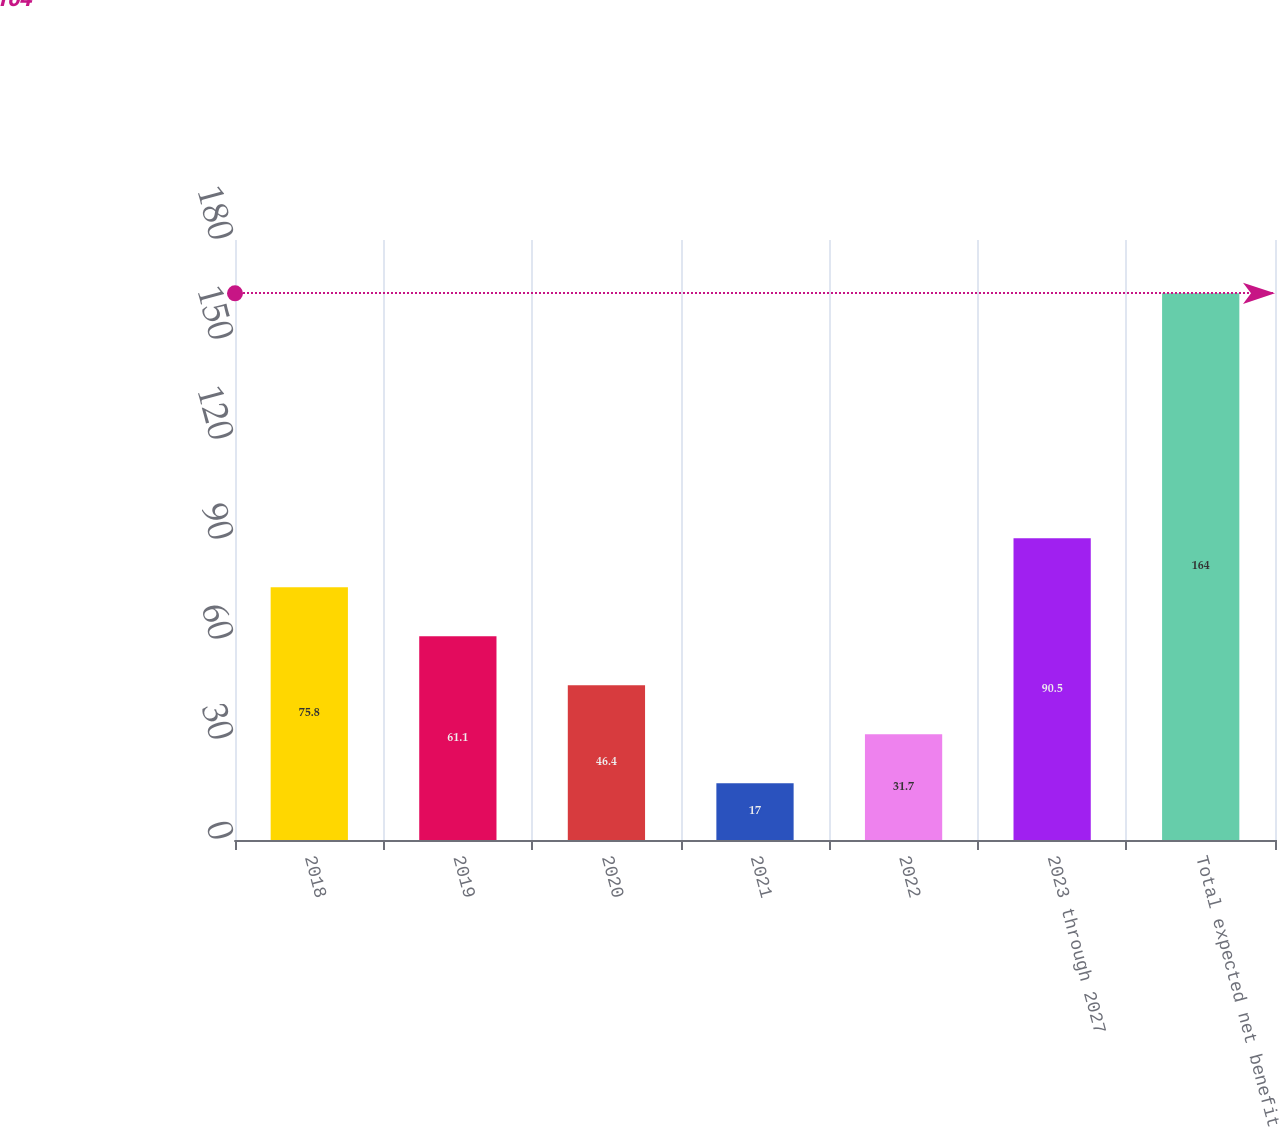Convert chart. <chart><loc_0><loc_0><loc_500><loc_500><bar_chart><fcel>2018<fcel>2019<fcel>2020<fcel>2021<fcel>2022<fcel>2023 through 2027<fcel>Total expected net benefit<nl><fcel>75.8<fcel>61.1<fcel>46.4<fcel>17<fcel>31.7<fcel>90.5<fcel>164<nl></chart> 